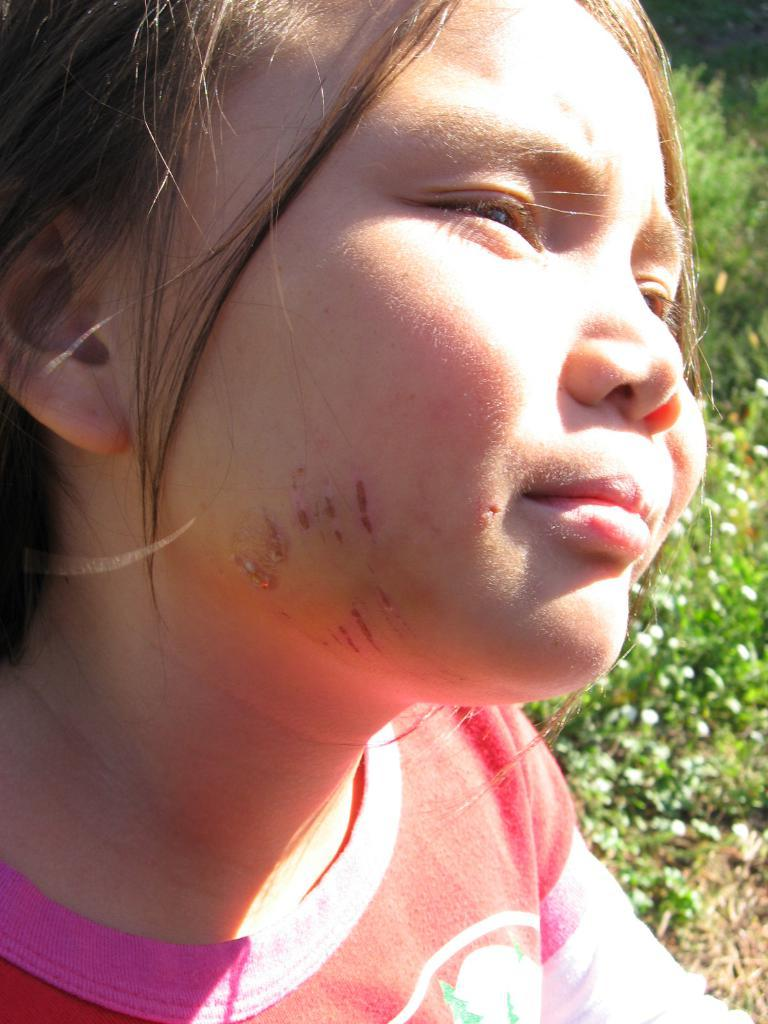Who is the main subject in the image? There is a girl in the center of the image. What can be seen on the right side of the image? There are plants on the right side of the image. What type of crime is being committed in the image? There is no crime being committed in the image; it features a girl and plants. What song is the girl singing in the image? There is no indication that the girl is singing in the image, so it cannot be determined from the picture. 